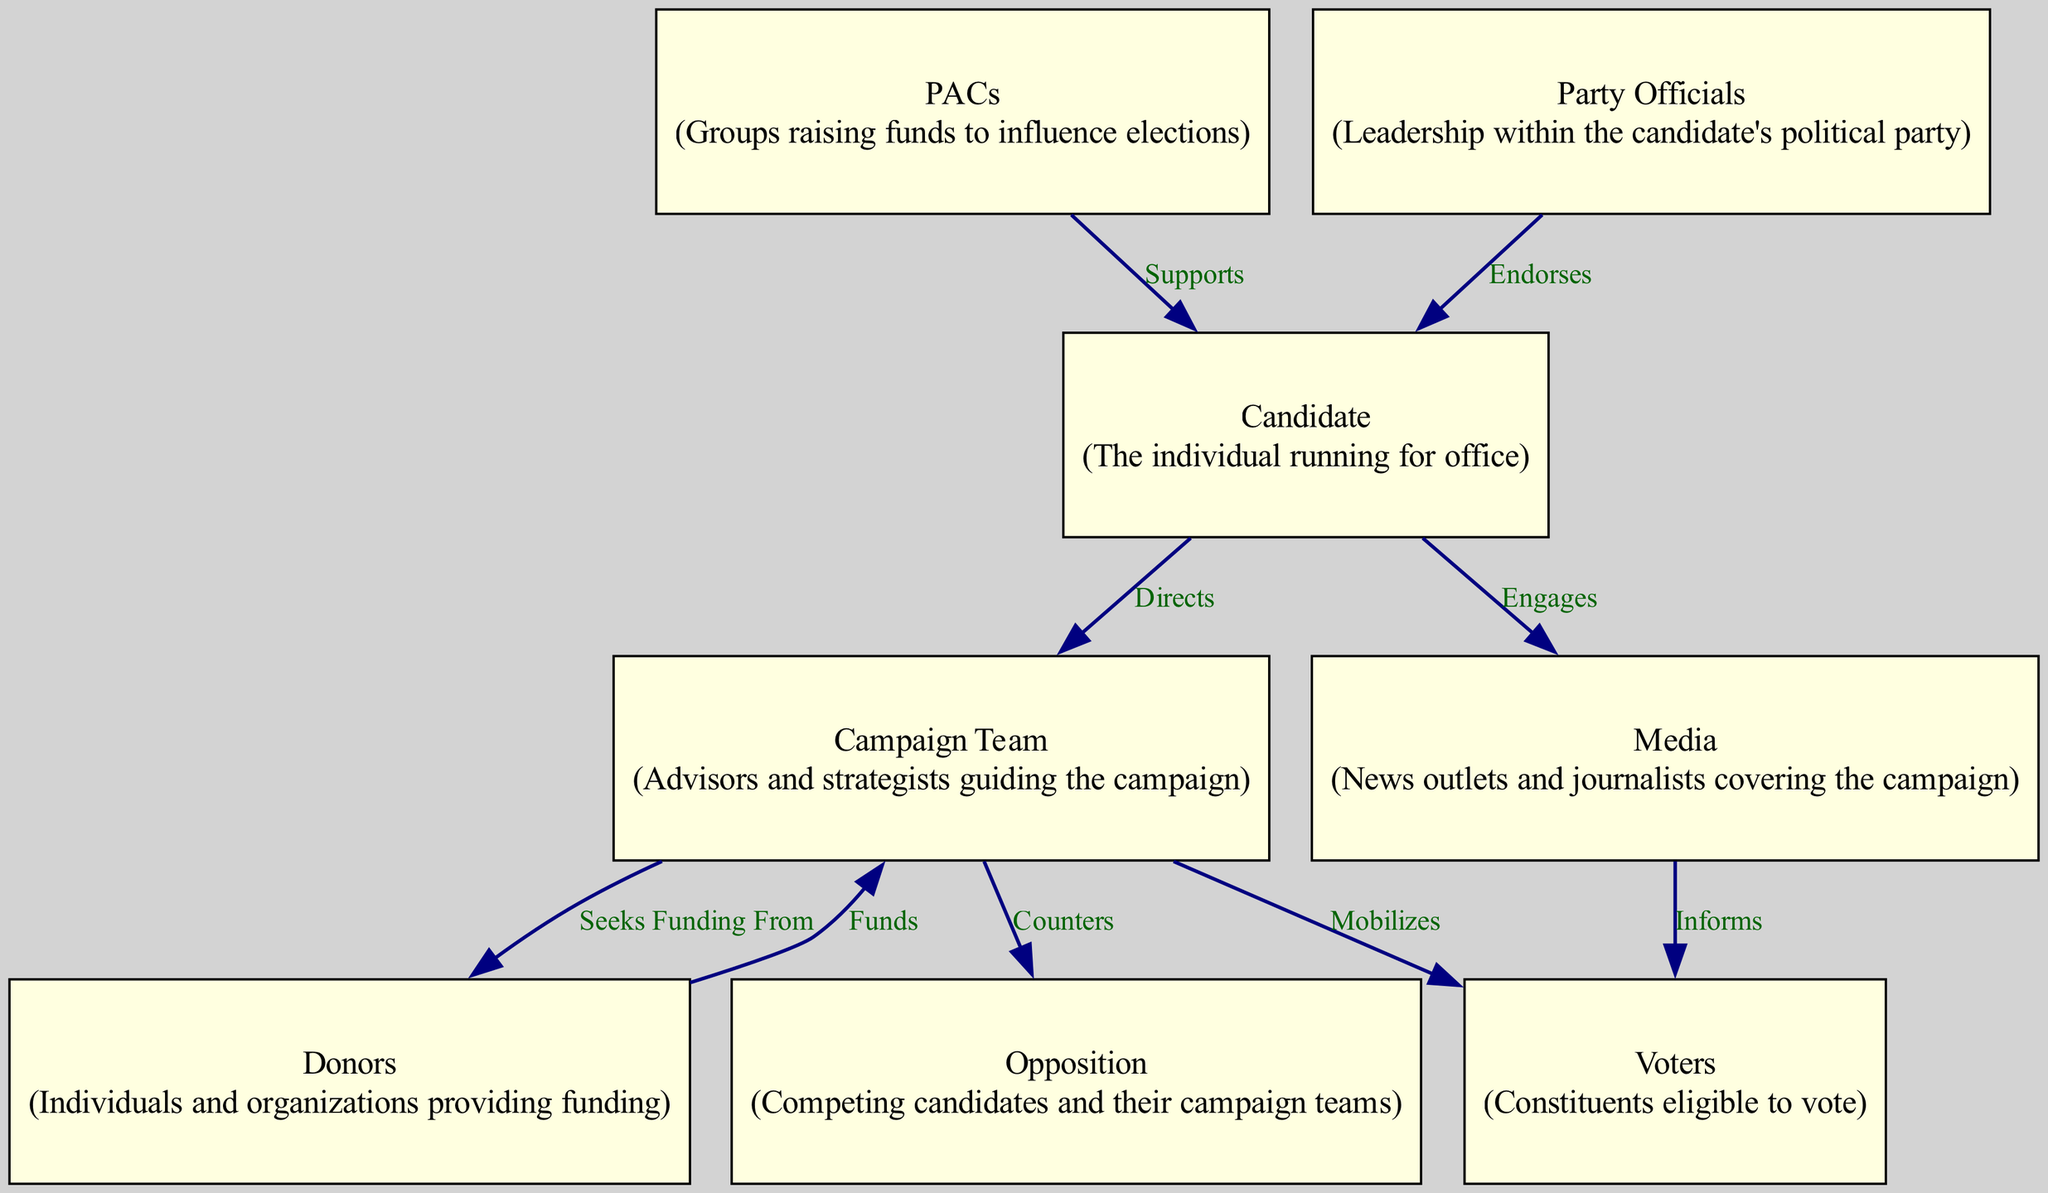What is the total number of nodes in the diagram? The diagram includes eight different nodes representing key stakeholders, such as the candidate, campaign team, voters, donors, media, opposition, PACs, and party officials. By counting each distinct node listed, we find there are eight.
Answer: 8 Which node is directed by the campaign team? The campaign team directs the voters, meaning there is an edge labeled "Mobilizes" that connects the campaign team to the voters in the diagram.
Answer: Voters How many edges originate from the candidate? The candidate has two outgoing edges: one that engages the media and another that directs the campaign team, so we can count both edges linking from the candidate to those two nodes.
Answer: 2 What type of node is the campaign team? The campaign team is represented as a hexagon shape in the diagram, which is specific to this stakeholder's representation.
Answer: Hexagon What is the relationship between donors and campaign team? Donors have a funding relationship with the campaign team, as indicated by the edge labeled "Funds" connecting the donors to the campaign team.
Answer: Funds Which stakeholders are directly connected to the candidate? The candidates are directly engaged with the media and directed by the campaign team. Examining the edges originating from the candidate shows these two relationships.
Answer: Media and Campaign Team Who endorses the candidate? Party officials are the stakeholders who endorse the candidate, as indicated by the edge labeled "Endorses" connecting them to the candidate.
Answer: Party Officials Which stakeholder informs the voters? The media is responsible for informing the voters, deduced from the edge labeled "Informs" connecting the media to the voters.
Answer: Media What role do political action committees play in this diagram? Political action committees support the candidate, as illustrated by the edge labeled "Supports" that links PACs to the candidate.
Answer: Supports 